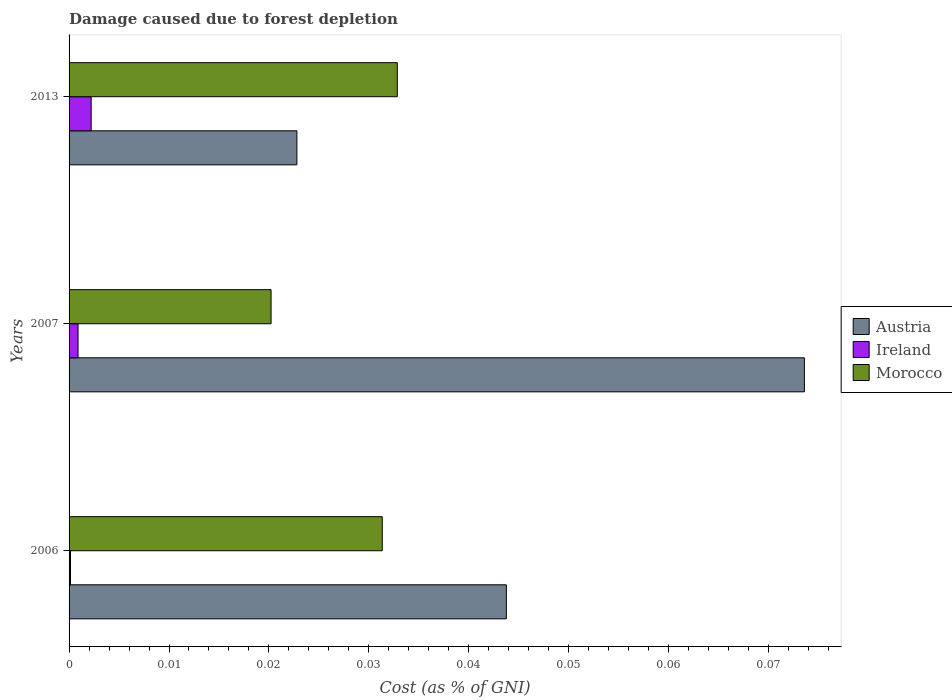How many different coloured bars are there?
Your answer should be compact. 3. How many groups of bars are there?
Give a very brief answer. 3. Are the number of bars per tick equal to the number of legend labels?
Your answer should be very brief. Yes. How many bars are there on the 2nd tick from the bottom?
Your answer should be very brief. 3. What is the label of the 1st group of bars from the top?
Your response must be concise. 2013. In how many cases, is the number of bars for a given year not equal to the number of legend labels?
Your answer should be very brief. 0. What is the cost of damage caused due to forest depletion in Austria in 2006?
Ensure brevity in your answer.  0.04. Across all years, what is the maximum cost of damage caused due to forest depletion in Ireland?
Offer a very short reply. 0. Across all years, what is the minimum cost of damage caused due to forest depletion in Austria?
Make the answer very short. 0.02. What is the total cost of damage caused due to forest depletion in Ireland in the graph?
Offer a terse response. 0. What is the difference between the cost of damage caused due to forest depletion in Austria in 2006 and that in 2007?
Ensure brevity in your answer.  -0.03. What is the difference between the cost of damage caused due to forest depletion in Ireland in 2013 and the cost of damage caused due to forest depletion in Morocco in 2007?
Make the answer very short. -0.02. What is the average cost of damage caused due to forest depletion in Morocco per year?
Ensure brevity in your answer.  0.03. In the year 2006, what is the difference between the cost of damage caused due to forest depletion in Austria and cost of damage caused due to forest depletion in Ireland?
Keep it short and to the point. 0.04. What is the ratio of the cost of damage caused due to forest depletion in Morocco in 2006 to that in 2007?
Provide a short and direct response. 1.55. What is the difference between the highest and the second highest cost of damage caused due to forest depletion in Morocco?
Your answer should be compact. 0. What is the difference between the highest and the lowest cost of damage caused due to forest depletion in Morocco?
Ensure brevity in your answer.  0.01. In how many years, is the cost of damage caused due to forest depletion in Ireland greater than the average cost of damage caused due to forest depletion in Ireland taken over all years?
Your answer should be very brief. 1. What does the 1st bar from the top in 2007 represents?
Your response must be concise. Morocco. What does the 2nd bar from the bottom in 2007 represents?
Your answer should be very brief. Ireland. Are all the bars in the graph horizontal?
Your response must be concise. Yes. What is the difference between two consecutive major ticks on the X-axis?
Keep it short and to the point. 0.01. Does the graph contain any zero values?
Provide a succinct answer. No. Where does the legend appear in the graph?
Ensure brevity in your answer.  Center right. What is the title of the graph?
Your answer should be compact. Damage caused due to forest depletion. Does "Nepal" appear as one of the legend labels in the graph?
Your response must be concise. No. What is the label or title of the X-axis?
Your answer should be very brief. Cost (as % of GNI). What is the Cost (as % of GNI) in Austria in 2006?
Offer a terse response. 0.04. What is the Cost (as % of GNI) of Ireland in 2006?
Your answer should be compact. 0. What is the Cost (as % of GNI) of Morocco in 2006?
Offer a very short reply. 0.03. What is the Cost (as % of GNI) in Austria in 2007?
Offer a terse response. 0.07. What is the Cost (as % of GNI) in Ireland in 2007?
Provide a succinct answer. 0. What is the Cost (as % of GNI) of Morocco in 2007?
Make the answer very short. 0.02. What is the Cost (as % of GNI) of Austria in 2013?
Offer a very short reply. 0.02. What is the Cost (as % of GNI) in Ireland in 2013?
Provide a short and direct response. 0. What is the Cost (as % of GNI) in Morocco in 2013?
Offer a very short reply. 0.03. Across all years, what is the maximum Cost (as % of GNI) in Austria?
Make the answer very short. 0.07. Across all years, what is the maximum Cost (as % of GNI) in Ireland?
Your answer should be very brief. 0. Across all years, what is the maximum Cost (as % of GNI) of Morocco?
Offer a terse response. 0.03. Across all years, what is the minimum Cost (as % of GNI) in Austria?
Make the answer very short. 0.02. Across all years, what is the minimum Cost (as % of GNI) of Ireland?
Offer a terse response. 0. Across all years, what is the minimum Cost (as % of GNI) in Morocco?
Make the answer very short. 0.02. What is the total Cost (as % of GNI) of Austria in the graph?
Offer a very short reply. 0.14. What is the total Cost (as % of GNI) in Ireland in the graph?
Your response must be concise. 0. What is the total Cost (as % of GNI) of Morocco in the graph?
Your answer should be compact. 0.08. What is the difference between the Cost (as % of GNI) of Austria in 2006 and that in 2007?
Keep it short and to the point. -0.03. What is the difference between the Cost (as % of GNI) of Ireland in 2006 and that in 2007?
Keep it short and to the point. -0. What is the difference between the Cost (as % of GNI) in Morocco in 2006 and that in 2007?
Ensure brevity in your answer.  0.01. What is the difference between the Cost (as % of GNI) of Austria in 2006 and that in 2013?
Your response must be concise. 0.02. What is the difference between the Cost (as % of GNI) in Ireland in 2006 and that in 2013?
Your response must be concise. -0. What is the difference between the Cost (as % of GNI) in Morocco in 2006 and that in 2013?
Ensure brevity in your answer.  -0. What is the difference between the Cost (as % of GNI) of Austria in 2007 and that in 2013?
Make the answer very short. 0.05. What is the difference between the Cost (as % of GNI) in Ireland in 2007 and that in 2013?
Keep it short and to the point. -0. What is the difference between the Cost (as % of GNI) in Morocco in 2007 and that in 2013?
Give a very brief answer. -0.01. What is the difference between the Cost (as % of GNI) in Austria in 2006 and the Cost (as % of GNI) in Ireland in 2007?
Your answer should be compact. 0.04. What is the difference between the Cost (as % of GNI) in Austria in 2006 and the Cost (as % of GNI) in Morocco in 2007?
Your answer should be very brief. 0.02. What is the difference between the Cost (as % of GNI) of Ireland in 2006 and the Cost (as % of GNI) of Morocco in 2007?
Your answer should be compact. -0.02. What is the difference between the Cost (as % of GNI) of Austria in 2006 and the Cost (as % of GNI) of Ireland in 2013?
Provide a short and direct response. 0.04. What is the difference between the Cost (as % of GNI) in Austria in 2006 and the Cost (as % of GNI) in Morocco in 2013?
Provide a succinct answer. 0.01. What is the difference between the Cost (as % of GNI) in Ireland in 2006 and the Cost (as % of GNI) in Morocco in 2013?
Make the answer very short. -0.03. What is the difference between the Cost (as % of GNI) of Austria in 2007 and the Cost (as % of GNI) of Ireland in 2013?
Your answer should be very brief. 0.07. What is the difference between the Cost (as % of GNI) in Austria in 2007 and the Cost (as % of GNI) in Morocco in 2013?
Provide a succinct answer. 0.04. What is the difference between the Cost (as % of GNI) in Ireland in 2007 and the Cost (as % of GNI) in Morocco in 2013?
Make the answer very short. -0.03. What is the average Cost (as % of GNI) of Austria per year?
Your response must be concise. 0.05. What is the average Cost (as % of GNI) of Ireland per year?
Make the answer very short. 0. What is the average Cost (as % of GNI) of Morocco per year?
Your response must be concise. 0.03. In the year 2006, what is the difference between the Cost (as % of GNI) in Austria and Cost (as % of GNI) in Ireland?
Your answer should be compact. 0.04. In the year 2006, what is the difference between the Cost (as % of GNI) in Austria and Cost (as % of GNI) in Morocco?
Ensure brevity in your answer.  0.01. In the year 2006, what is the difference between the Cost (as % of GNI) in Ireland and Cost (as % of GNI) in Morocco?
Your response must be concise. -0.03. In the year 2007, what is the difference between the Cost (as % of GNI) in Austria and Cost (as % of GNI) in Ireland?
Your answer should be very brief. 0.07. In the year 2007, what is the difference between the Cost (as % of GNI) of Austria and Cost (as % of GNI) of Morocco?
Keep it short and to the point. 0.05. In the year 2007, what is the difference between the Cost (as % of GNI) of Ireland and Cost (as % of GNI) of Morocco?
Give a very brief answer. -0.02. In the year 2013, what is the difference between the Cost (as % of GNI) of Austria and Cost (as % of GNI) of Ireland?
Make the answer very short. 0.02. In the year 2013, what is the difference between the Cost (as % of GNI) of Austria and Cost (as % of GNI) of Morocco?
Provide a short and direct response. -0.01. In the year 2013, what is the difference between the Cost (as % of GNI) in Ireland and Cost (as % of GNI) in Morocco?
Your response must be concise. -0.03. What is the ratio of the Cost (as % of GNI) in Austria in 2006 to that in 2007?
Provide a short and direct response. 0.59. What is the ratio of the Cost (as % of GNI) of Ireland in 2006 to that in 2007?
Your answer should be very brief. 0.16. What is the ratio of the Cost (as % of GNI) of Morocco in 2006 to that in 2007?
Provide a succinct answer. 1.55. What is the ratio of the Cost (as % of GNI) of Austria in 2006 to that in 2013?
Offer a very short reply. 1.92. What is the ratio of the Cost (as % of GNI) in Ireland in 2006 to that in 2013?
Your answer should be compact. 0.07. What is the ratio of the Cost (as % of GNI) of Morocco in 2006 to that in 2013?
Keep it short and to the point. 0.95. What is the ratio of the Cost (as % of GNI) of Austria in 2007 to that in 2013?
Give a very brief answer. 3.23. What is the ratio of the Cost (as % of GNI) in Ireland in 2007 to that in 2013?
Offer a terse response. 0.41. What is the ratio of the Cost (as % of GNI) in Morocco in 2007 to that in 2013?
Your answer should be compact. 0.62. What is the difference between the highest and the second highest Cost (as % of GNI) in Austria?
Provide a succinct answer. 0.03. What is the difference between the highest and the second highest Cost (as % of GNI) of Ireland?
Ensure brevity in your answer.  0. What is the difference between the highest and the second highest Cost (as % of GNI) of Morocco?
Make the answer very short. 0. What is the difference between the highest and the lowest Cost (as % of GNI) of Austria?
Your response must be concise. 0.05. What is the difference between the highest and the lowest Cost (as % of GNI) of Ireland?
Provide a short and direct response. 0. What is the difference between the highest and the lowest Cost (as % of GNI) in Morocco?
Your answer should be compact. 0.01. 